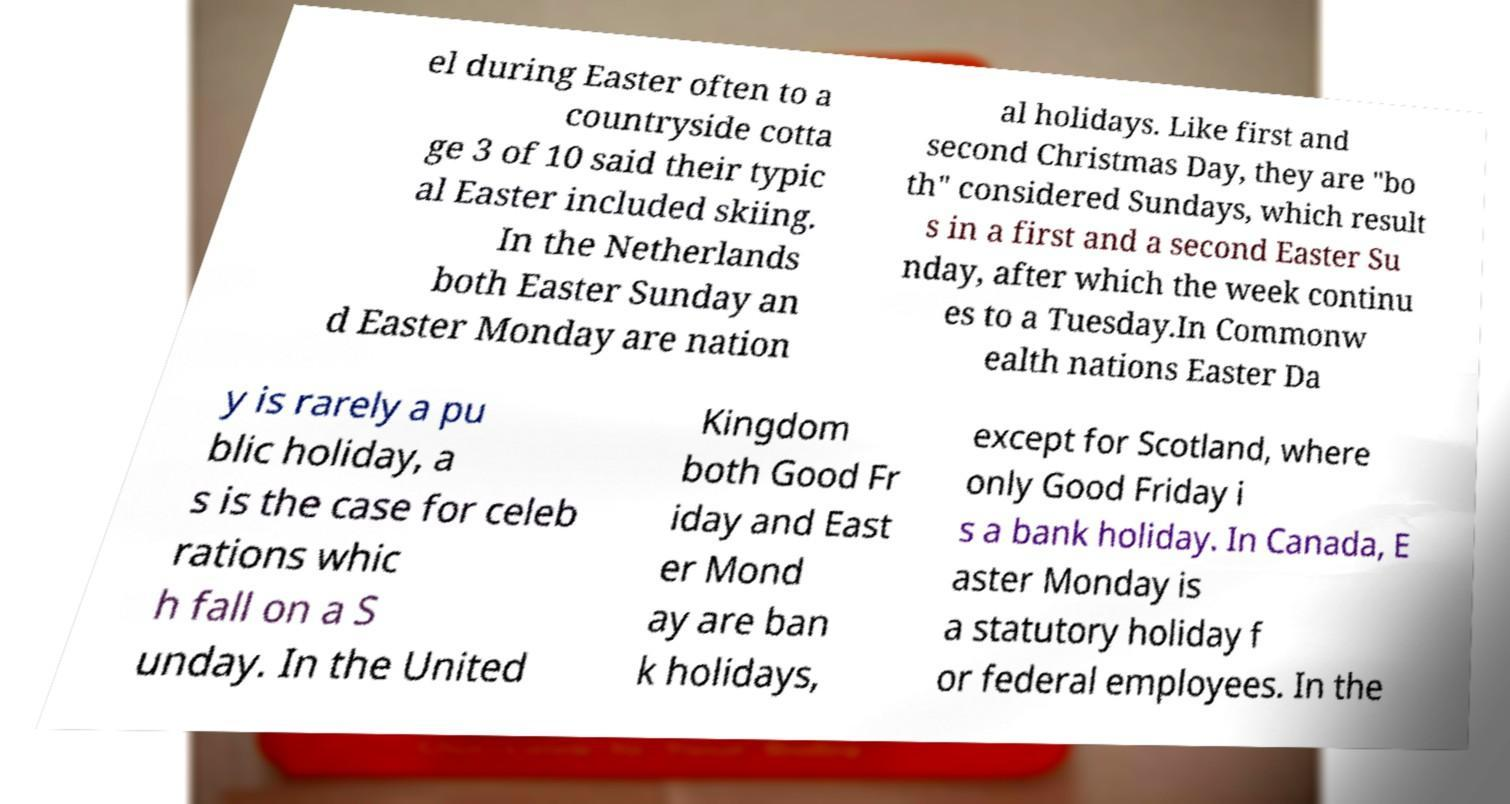There's text embedded in this image that I need extracted. Can you transcribe it verbatim? el during Easter often to a countryside cotta ge 3 of 10 said their typic al Easter included skiing. In the Netherlands both Easter Sunday an d Easter Monday are nation al holidays. Like first and second Christmas Day, they are "bo th" considered Sundays, which result s in a first and a second Easter Su nday, after which the week continu es to a Tuesday.In Commonw ealth nations Easter Da y is rarely a pu blic holiday, a s is the case for celeb rations whic h fall on a S unday. In the United Kingdom both Good Fr iday and East er Mond ay are ban k holidays, except for Scotland, where only Good Friday i s a bank holiday. In Canada, E aster Monday is a statutory holiday f or federal employees. In the 